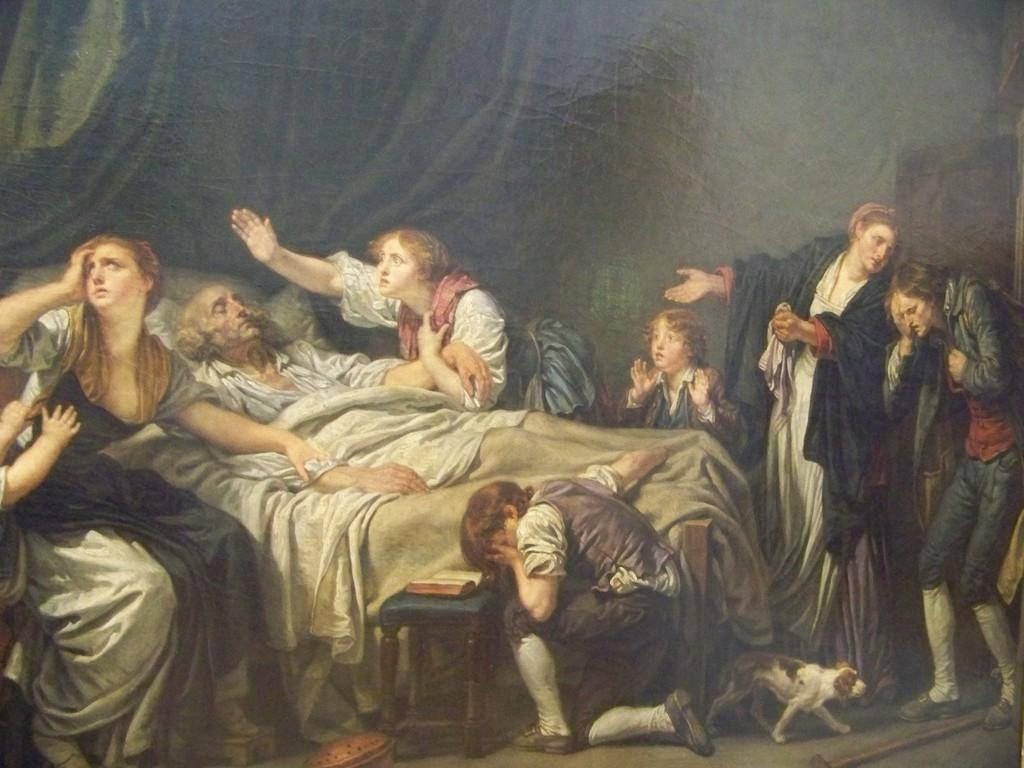What type of objects are depicted in the pictures in the image? There are pictures of persons in the image. What else can be seen in the image besides the pictures? There are clothes, a stool, a book, a stick, and a dog in the image. What might the person in the picture be sitting on? The person in the picture might be sitting on the stool. What is the dog doing in the image? The dog's actions are not specified, but it is present in the image. What is the color of the background in the image? The background of the image is dark. What type of flag is being waved by the beast in the image? There is no flag or beast present in the image. What is the temper of the person in the picture? The temper of the person in the picture cannot be determined from the image. 